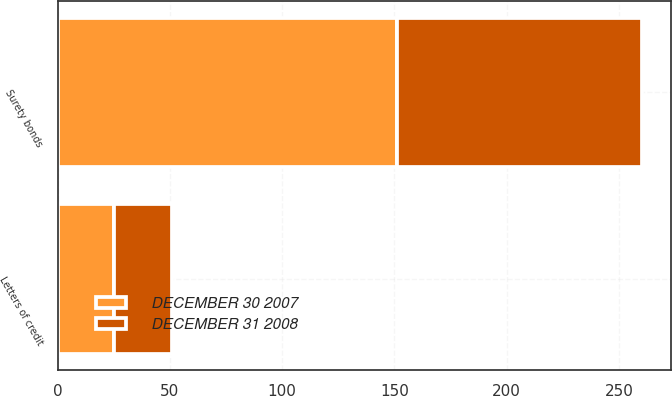Convert chart. <chart><loc_0><loc_0><loc_500><loc_500><stacked_bar_chart><ecel><fcel>Letters of credit<fcel>Surety bonds<nl><fcel>DECEMBER 31 2008<fcel>26<fcel>109<nl><fcel>DECEMBER 30 2007<fcel>25<fcel>151<nl></chart> 